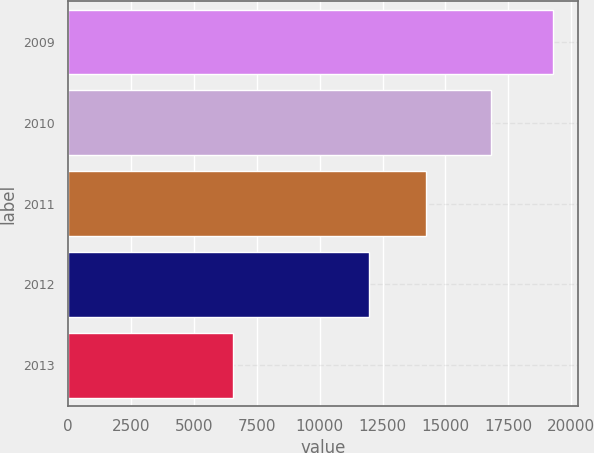<chart> <loc_0><loc_0><loc_500><loc_500><bar_chart><fcel>2009<fcel>2010<fcel>2011<fcel>2012<fcel>2013<nl><fcel>19285<fcel>16804<fcel>14226<fcel>11942<fcel>6570<nl></chart> 